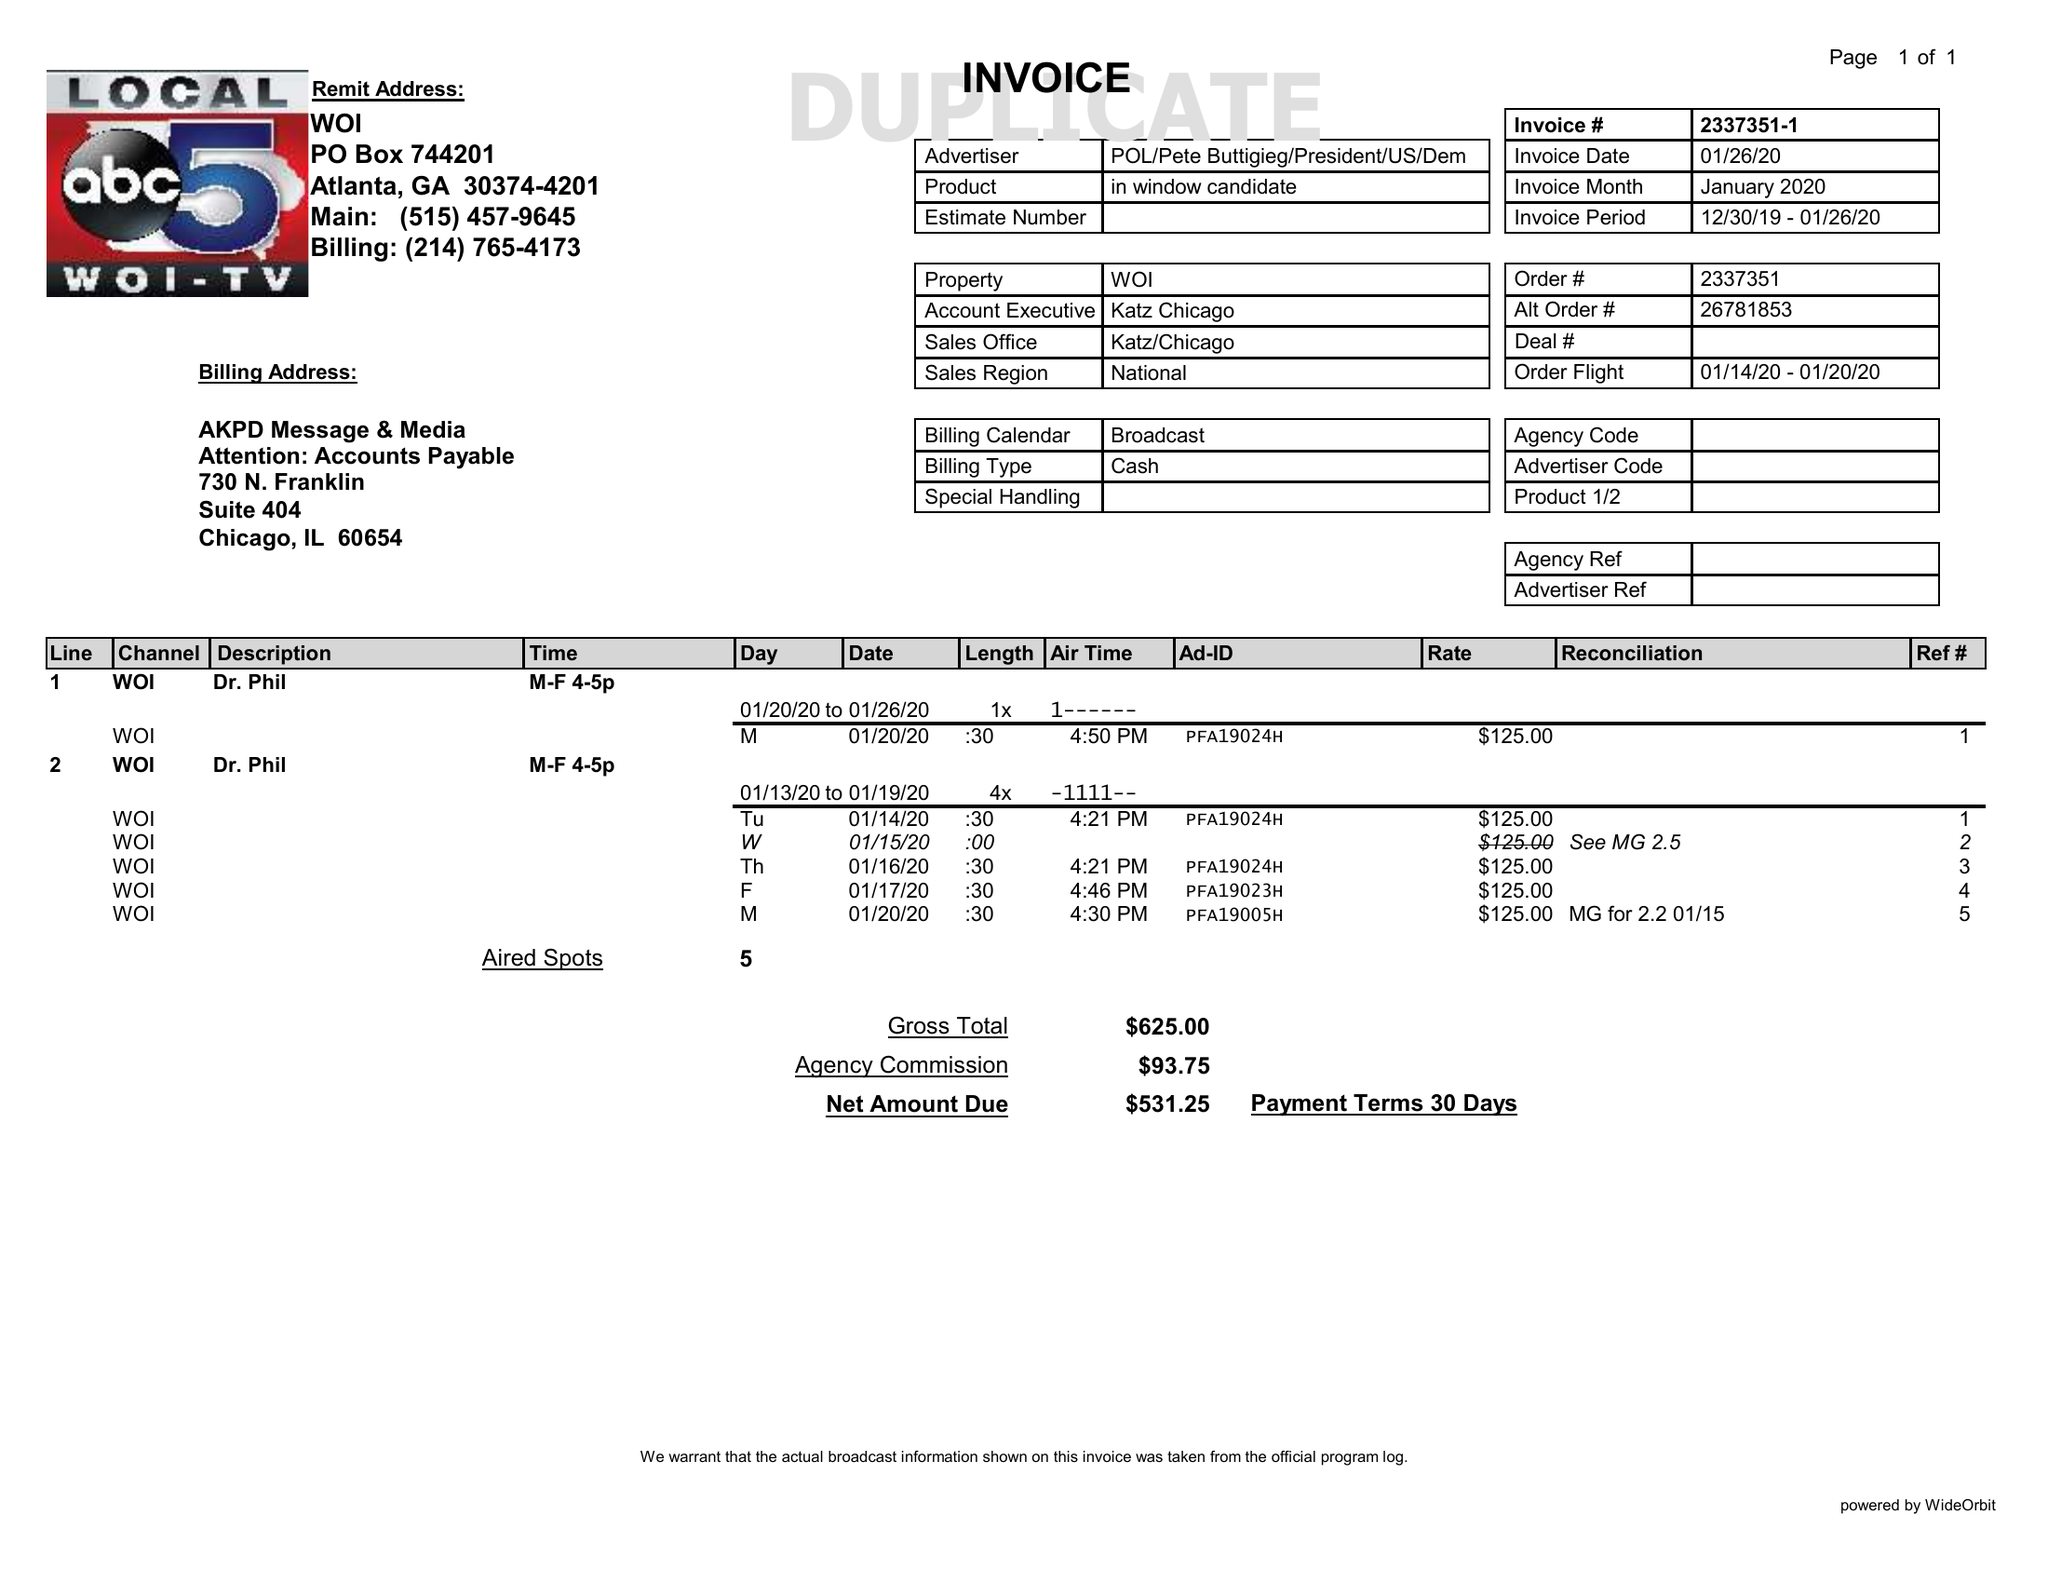What is the value for the flight_from?
Answer the question using a single word or phrase. 01/14/20 